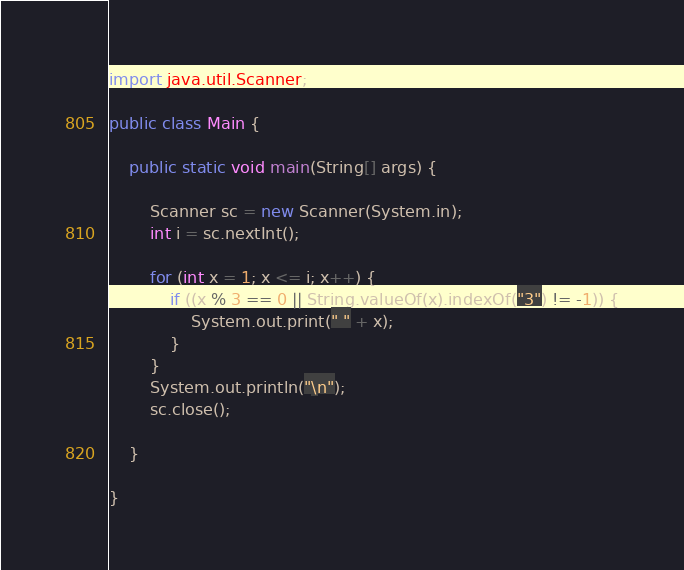<code> <loc_0><loc_0><loc_500><loc_500><_Java_>import java.util.Scanner;

public class Main {

	public static void main(String[] args) {

		Scanner sc = new Scanner(System.in);
		int i = sc.nextInt();

		for (int x = 1; x <= i; x++) {
			if ((x % 3 == 0 || String.valueOf(x).indexOf("3") != -1)) {
				System.out.print(" " + x);
			}
		}
		System.out.println("\n");
		sc.close();

	}

}</code> 